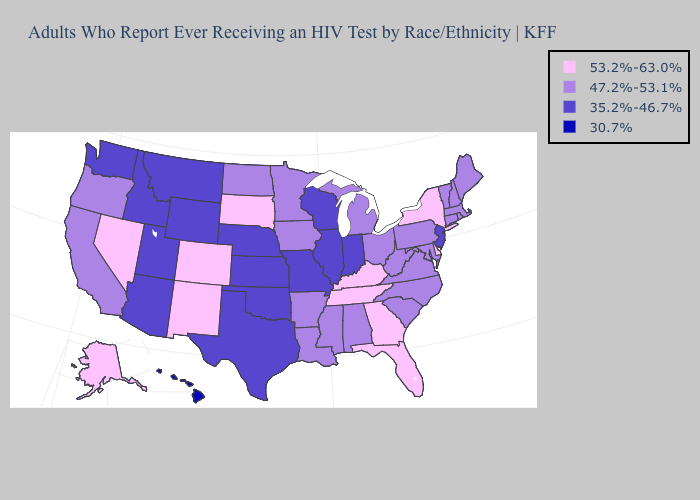Name the states that have a value in the range 35.2%-46.7%?
Write a very short answer. Arizona, Idaho, Illinois, Indiana, Kansas, Missouri, Montana, Nebraska, New Jersey, Oklahoma, Texas, Utah, Washington, Wisconsin, Wyoming. What is the highest value in states that border South Dakota?
Write a very short answer. 47.2%-53.1%. Name the states that have a value in the range 53.2%-63.0%?
Concise answer only. Alaska, Colorado, Delaware, Florida, Georgia, Kentucky, Nevada, New Mexico, New York, South Dakota, Tennessee. Does Tennessee have the highest value in the South?
Keep it brief. Yes. What is the value of Minnesota?
Give a very brief answer. 47.2%-53.1%. What is the lowest value in the South?
Give a very brief answer. 35.2%-46.7%. Among the states that border Mississippi , does Tennessee have the highest value?
Keep it brief. Yes. Does Pennsylvania have the lowest value in the USA?
Concise answer only. No. What is the value of Iowa?
Write a very short answer. 47.2%-53.1%. What is the value of Louisiana?
Keep it brief. 47.2%-53.1%. Name the states that have a value in the range 47.2%-53.1%?
Write a very short answer. Alabama, Arkansas, California, Connecticut, Iowa, Louisiana, Maine, Maryland, Massachusetts, Michigan, Minnesota, Mississippi, New Hampshire, North Carolina, North Dakota, Ohio, Oregon, Pennsylvania, Rhode Island, South Carolina, Vermont, Virginia, West Virginia. Name the states that have a value in the range 53.2%-63.0%?
Quick response, please. Alaska, Colorado, Delaware, Florida, Georgia, Kentucky, Nevada, New Mexico, New York, South Dakota, Tennessee. Which states hav the highest value in the MidWest?
Short answer required. South Dakota. What is the value of Nebraska?
Be succinct. 35.2%-46.7%. 